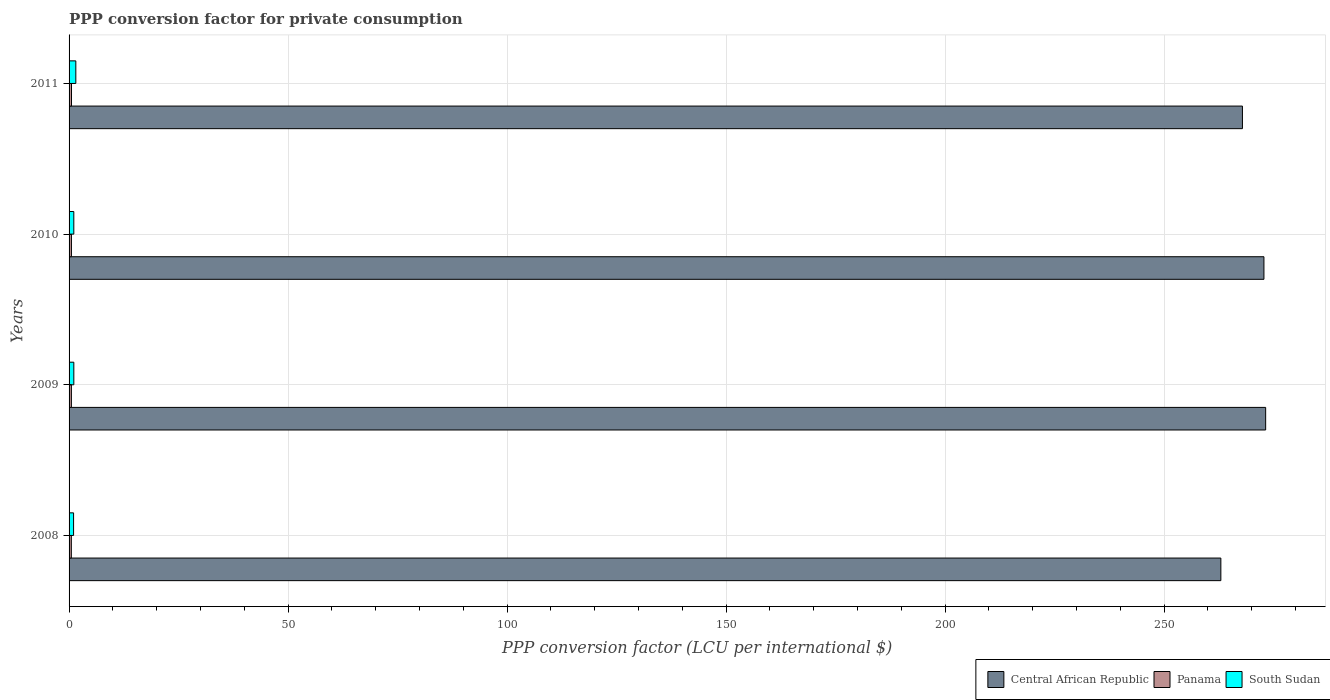Are the number of bars per tick equal to the number of legend labels?
Offer a terse response. Yes. Are the number of bars on each tick of the Y-axis equal?
Your answer should be very brief. Yes. What is the label of the 4th group of bars from the top?
Provide a short and direct response. 2008. In how many cases, is the number of bars for a given year not equal to the number of legend labels?
Ensure brevity in your answer.  0. What is the PPP conversion factor for private consumption in Central African Republic in 2011?
Provide a succinct answer. 267.87. Across all years, what is the maximum PPP conversion factor for private consumption in Panama?
Keep it short and to the point. 0.55. Across all years, what is the minimum PPP conversion factor for private consumption in Central African Republic?
Your answer should be compact. 262.95. In which year was the PPP conversion factor for private consumption in Central African Republic minimum?
Provide a succinct answer. 2008. What is the total PPP conversion factor for private consumption in Panama in the graph?
Keep it short and to the point. 2.14. What is the difference between the PPP conversion factor for private consumption in Central African Republic in 2008 and that in 2011?
Offer a terse response. -4.92. What is the difference between the PPP conversion factor for private consumption in Central African Republic in 2010 and the PPP conversion factor for private consumption in Panama in 2009?
Ensure brevity in your answer.  272.25. What is the average PPP conversion factor for private consumption in Panama per year?
Your response must be concise. 0.53. In the year 2008, what is the difference between the PPP conversion factor for private consumption in Central African Republic and PPP conversion factor for private consumption in Panama?
Make the answer very short. 262.43. What is the ratio of the PPP conversion factor for private consumption in Central African Republic in 2009 to that in 2011?
Your answer should be very brief. 1.02. What is the difference between the highest and the second highest PPP conversion factor for private consumption in Panama?
Your answer should be very brief. 0.01. What is the difference between the highest and the lowest PPP conversion factor for private consumption in Central African Republic?
Your answer should be compact. 10.23. In how many years, is the PPP conversion factor for private consumption in Panama greater than the average PPP conversion factor for private consumption in Panama taken over all years?
Your answer should be very brief. 2. Is the sum of the PPP conversion factor for private consumption in Panama in 2010 and 2011 greater than the maximum PPP conversion factor for private consumption in Central African Republic across all years?
Offer a terse response. No. What does the 3rd bar from the top in 2010 represents?
Your answer should be very brief. Central African Republic. What does the 1st bar from the bottom in 2008 represents?
Make the answer very short. Central African Republic. Are all the bars in the graph horizontal?
Offer a terse response. Yes. How many years are there in the graph?
Your answer should be compact. 4. Does the graph contain any zero values?
Provide a succinct answer. No. Where does the legend appear in the graph?
Provide a short and direct response. Bottom right. How are the legend labels stacked?
Provide a short and direct response. Horizontal. What is the title of the graph?
Make the answer very short. PPP conversion factor for private consumption. Does "Seychelles" appear as one of the legend labels in the graph?
Offer a terse response. No. What is the label or title of the X-axis?
Offer a terse response. PPP conversion factor (LCU per international $). What is the PPP conversion factor (LCU per international $) in Central African Republic in 2008?
Provide a short and direct response. 262.95. What is the PPP conversion factor (LCU per international $) in Panama in 2008?
Your answer should be very brief. 0.52. What is the PPP conversion factor (LCU per international $) of South Sudan in 2008?
Your answer should be compact. 1.03. What is the PPP conversion factor (LCU per international $) in Central African Republic in 2009?
Ensure brevity in your answer.  273.17. What is the PPP conversion factor (LCU per international $) of Panama in 2009?
Your response must be concise. 0.53. What is the PPP conversion factor (LCU per international $) of South Sudan in 2009?
Provide a short and direct response. 1.09. What is the PPP conversion factor (LCU per international $) in Central African Republic in 2010?
Give a very brief answer. 272.78. What is the PPP conversion factor (LCU per international $) of Panama in 2010?
Provide a short and direct response. 0.54. What is the PPP conversion factor (LCU per international $) in South Sudan in 2010?
Your answer should be very brief. 1.08. What is the PPP conversion factor (LCU per international $) of Central African Republic in 2011?
Keep it short and to the point. 267.87. What is the PPP conversion factor (LCU per international $) of Panama in 2011?
Keep it short and to the point. 0.55. What is the PPP conversion factor (LCU per international $) of South Sudan in 2011?
Keep it short and to the point. 1.54. Across all years, what is the maximum PPP conversion factor (LCU per international $) of Central African Republic?
Your answer should be compact. 273.17. Across all years, what is the maximum PPP conversion factor (LCU per international $) in Panama?
Provide a succinct answer. 0.55. Across all years, what is the maximum PPP conversion factor (LCU per international $) in South Sudan?
Provide a succinct answer. 1.54. Across all years, what is the minimum PPP conversion factor (LCU per international $) of Central African Republic?
Offer a terse response. 262.95. Across all years, what is the minimum PPP conversion factor (LCU per international $) in Panama?
Your answer should be very brief. 0.52. Across all years, what is the minimum PPP conversion factor (LCU per international $) of South Sudan?
Your response must be concise. 1.03. What is the total PPP conversion factor (LCU per international $) in Central African Republic in the graph?
Provide a short and direct response. 1076.76. What is the total PPP conversion factor (LCU per international $) in Panama in the graph?
Offer a very short reply. 2.14. What is the total PPP conversion factor (LCU per international $) in South Sudan in the graph?
Provide a succinct answer. 4.74. What is the difference between the PPP conversion factor (LCU per international $) in Central African Republic in 2008 and that in 2009?
Offer a terse response. -10.23. What is the difference between the PPP conversion factor (LCU per international $) of Panama in 2008 and that in 2009?
Your answer should be compact. -0.01. What is the difference between the PPP conversion factor (LCU per international $) of South Sudan in 2008 and that in 2009?
Offer a terse response. -0.06. What is the difference between the PPP conversion factor (LCU per international $) of Central African Republic in 2008 and that in 2010?
Provide a short and direct response. -9.83. What is the difference between the PPP conversion factor (LCU per international $) in Panama in 2008 and that in 2010?
Your answer should be compact. -0.02. What is the difference between the PPP conversion factor (LCU per international $) of South Sudan in 2008 and that in 2010?
Your response must be concise. -0.05. What is the difference between the PPP conversion factor (LCU per international $) in Central African Republic in 2008 and that in 2011?
Your response must be concise. -4.92. What is the difference between the PPP conversion factor (LCU per international $) in Panama in 2008 and that in 2011?
Provide a short and direct response. -0.04. What is the difference between the PPP conversion factor (LCU per international $) in South Sudan in 2008 and that in 2011?
Give a very brief answer. -0.51. What is the difference between the PPP conversion factor (LCU per international $) in Central African Republic in 2009 and that in 2010?
Ensure brevity in your answer.  0.39. What is the difference between the PPP conversion factor (LCU per international $) of Panama in 2009 and that in 2010?
Your answer should be very brief. -0.01. What is the difference between the PPP conversion factor (LCU per international $) of South Sudan in 2009 and that in 2010?
Provide a succinct answer. 0.01. What is the difference between the PPP conversion factor (LCU per international $) of Central African Republic in 2009 and that in 2011?
Provide a short and direct response. 5.3. What is the difference between the PPP conversion factor (LCU per international $) in Panama in 2009 and that in 2011?
Provide a succinct answer. -0.02. What is the difference between the PPP conversion factor (LCU per international $) in South Sudan in 2009 and that in 2011?
Provide a short and direct response. -0.46. What is the difference between the PPP conversion factor (LCU per international $) of Central African Republic in 2010 and that in 2011?
Keep it short and to the point. 4.91. What is the difference between the PPP conversion factor (LCU per international $) in Panama in 2010 and that in 2011?
Ensure brevity in your answer.  -0.01. What is the difference between the PPP conversion factor (LCU per international $) of South Sudan in 2010 and that in 2011?
Give a very brief answer. -0.46. What is the difference between the PPP conversion factor (LCU per international $) of Central African Republic in 2008 and the PPP conversion factor (LCU per international $) of Panama in 2009?
Ensure brevity in your answer.  262.42. What is the difference between the PPP conversion factor (LCU per international $) of Central African Republic in 2008 and the PPP conversion factor (LCU per international $) of South Sudan in 2009?
Ensure brevity in your answer.  261.86. What is the difference between the PPP conversion factor (LCU per international $) in Panama in 2008 and the PPP conversion factor (LCU per international $) in South Sudan in 2009?
Provide a succinct answer. -0.57. What is the difference between the PPP conversion factor (LCU per international $) of Central African Republic in 2008 and the PPP conversion factor (LCU per international $) of Panama in 2010?
Make the answer very short. 262.41. What is the difference between the PPP conversion factor (LCU per international $) in Central African Republic in 2008 and the PPP conversion factor (LCU per international $) in South Sudan in 2010?
Make the answer very short. 261.86. What is the difference between the PPP conversion factor (LCU per international $) of Panama in 2008 and the PPP conversion factor (LCU per international $) of South Sudan in 2010?
Your answer should be compact. -0.57. What is the difference between the PPP conversion factor (LCU per international $) in Central African Republic in 2008 and the PPP conversion factor (LCU per international $) in Panama in 2011?
Your response must be concise. 262.39. What is the difference between the PPP conversion factor (LCU per international $) of Central African Republic in 2008 and the PPP conversion factor (LCU per international $) of South Sudan in 2011?
Offer a terse response. 261.4. What is the difference between the PPP conversion factor (LCU per international $) of Panama in 2008 and the PPP conversion factor (LCU per international $) of South Sudan in 2011?
Provide a succinct answer. -1.03. What is the difference between the PPP conversion factor (LCU per international $) of Central African Republic in 2009 and the PPP conversion factor (LCU per international $) of Panama in 2010?
Offer a terse response. 272.63. What is the difference between the PPP conversion factor (LCU per international $) in Central African Republic in 2009 and the PPP conversion factor (LCU per international $) in South Sudan in 2010?
Make the answer very short. 272.09. What is the difference between the PPP conversion factor (LCU per international $) of Panama in 2009 and the PPP conversion factor (LCU per international $) of South Sudan in 2010?
Keep it short and to the point. -0.55. What is the difference between the PPP conversion factor (LCU per international $) in Central African Republic in 2009 and the PPP conversion factor (LCU per international $) in Panama in 2011?
Ensure brevity in your answer.  272.62. What is the difference between the PPP conversion factor (LCU per international $) of Central African Republic in 2009 and the PPP conversion factor (LCU per international $) of South Sudan in 2011?
Ensure brevity in your answer.  271.63. What is the difference between the PPP conversion factor (LCU per international $) of Panama in 2009 and the PPP conversion factor (LCU per international $) of South Sudan in 2011?
Your answer should be very brief. -1.01. What is the difference between the PPP conversion factor (LCU per international $) of Central African Republic in 2010 and the PPP conversion factor (LCU per international $) of Panama in 2011?
Your answer should be very brief. 272.22. What is the difference between the PPP conversion factor (LCU per international $) in Central African Republic in 2010 and the PPP conversion factor (LCU per international $) in South Sudan in 2011?
Offer a very short reply. 271.23. What is the difference between the PPP conversion factor (LCU per international $) in Panama in 2010 and the PPP conversion factor (LCU per international $) in South Sudan in 2011?
Your answer should be very brief. -1. What is the average PPP conversion factor (LCU per international $) in Central African Republic per year?
Give a very brief answer. 269.19. What is the average PPP conversion factor (LCU per international $) in Panama per year?
Your answer should be compact. 0.53. What is the average PPP conversion factor (LCU per international $) of South Sudan per year?
Keep it short and to the point. 1.19. In the year 2008, what is the difference between the PPP conversion factor (LCU per international $) of Central African Republic and PPP conversion factor (LCU per international $) of Panama?
Ensure brevity in your answer.  262.43. In the year 2008, what is the difference between the PPP conversion factor (LCU per international $) in Central African Republic and PPP conversion factor (LCU per international $) in South Sudan?
Your answer should be very brief. 261.92. In the year 2008, what is the difference between the PPP conversion factor (LCU per international $) of Panama and PPP conversion factor (LCU per international $) of South Sudan?
Provide a succinct answer. -0.52. In the year 2009, what is the difference between the PPP conversion factor (LCU per international $) of Central African Republic and PPP conversion factor (LCU per international $) of Panama?
Keep it short and to the point. 272.64. In the year 2009, what is the difference between the PPP conversion factor (LCU per international $) in Central African Republic and PPP conversion factor (LCU per international $) in South Sudan?
Offer a very short reply. 272.09. In the year 2009, what is the difference between the PPP conversion factor (LCU per international $) in Panama and PPP conversion factor (LCU per international $) in South Sudan?
Provide a short and direct response. -0.56. In the year 2010, what is the difference between the PPP conversion factor (LCU per international $) in Central African Republic and PPP conversion factor (LCU per international $) in Panama?
Your answer should be compact. 272.24. In the year 2010, what is the difference between the PPP conversion factor (LCU per international $) of Central African Republic and PPP conversion factor (LCU per international $) of South Sudan?
Keep it short and to the point. 271.7. In the year 2010, what is the difference between the PPP conversion factor (LCU per international $) of Panama and PPP conversion factor (LCU per international $) of South Sudan?
Provide a succinct answer. -0.54. In the year 2011, what is the difference between the PPP conversion factor (LCU per international $) of Central African Republic and PPP conversion factor (LCU per international $) of Panama?
Your response must be concise. 267.32. In the year 2011, what is the difference between the PPP conversion factor (LCU per international $) in Central African Republic and PPP conversion factor (LCU per international $) in South Sudan?
Keep it short and to the point. 266.33. In the year 2011, what is the difference between the PPP conversion factor (LCU per international $) of Panama and PPP conversion factor (LCU per international $) of South Sudan?
Provide a succinct answer. -0.99. What is the ratio of the PPP conversion factor (LCU per international $) of Central African Republic in 2008 to that in 2009?
Provide a short and direct response. 0.96. What is the ratio of the PPP conversion factor (LCU per international $) in South Sudan in 2008 to that in 2009?
Make the answer very short. 0.95. What is the ratio of the PPP conversion factor (LCU per international $) in Central African Republic in 2008 to that in 2010?
Offer a very short reply. 0.96. What is the ratio of the PPP conversion factor (LCU per international $) in Panama in 2008 to that in 2010?
Ensure brevity in your answer.  0.96. What is the ratio of the PPP conversion factor (LCU per international $) in South Sudan in 2008 to that in 2010?
Your response must be concise. 0.95. What is the ratio of the PPP conversion factor (LCU per international $) in Central African Republic in 2008 to that in 2011?
Your answer should be very brief. 0.98. What is the ratio of the PPP conversion factor (LCU per international $) in Panama in 2008 to that in 2011?
Your answer should be compact. 0.93. What is the ratio of the PPP conversion factor (LCU per international $) in South Sudan in 2008 to that in 2011?
Offer a very short reply. 0.67. What is the ratio of the PPP conversion factor (LCU per international $) in Panama in 2009 to that in 2010?
Keep it short and to the point. 0.98. What is the ratio of the PPP conversion factor (LCU per international $) of Central African Republic in 2009 to that in 2011?
Make the answer very short. 1.02. What is the ratio of the PPP conversion factor (LCU per international $) in Panama in 2009 to that in 2011?
Make the answer very short. 0.96. What is the ratio of the PPP conversion factor (LCU per international $) of South Sudan in 2009 to that in 2011?
Provide a succinct answer. 0.7. What is the ratio of the PPP conversion factor (LCU per international $) of Central African Republic in 2010 to that in 2011?
Your response must be concise. 1.02. What is the ratio of the PPP conversion factor (LCU per international $) in Panama in 2010 to that in 2011?
Provide a succinct answer. 0.97. What is the ratio of the PPP conversion factor (LCU per international $) in South Sudan in 2010 to that in 2011?
Provide a succinct answer. 0.7. What is the difference between the highest and the second highest PPP conversion factor (LCU per international $) in Central African Republic?
Ensure brevity in your answer.  0.39. What is the difference between the highest and the second highest PPP conversion factor (LCU per international $) of Panama?
Keep it short and to the point. 0.01. What is the difference between the highest and the second highest PPP conversion factor (LCU per international $) in South Sudan?
Your answer should be very brief. 0.46. What is the difference between the highest and the lowest PPP conversion factor (LCU per international $) of Central African Republic?
Your response must be concise. 10.23. What is the difference between the highest and the lowest PPP conversion factor (LCU per international $) in Panama?
Offer a terse response. 0.04. What is the difference between the highest and the lowest PPP conversion factor (LCU per international $) in South Sudan?
Ensure brevity in your answer.  0.51. 